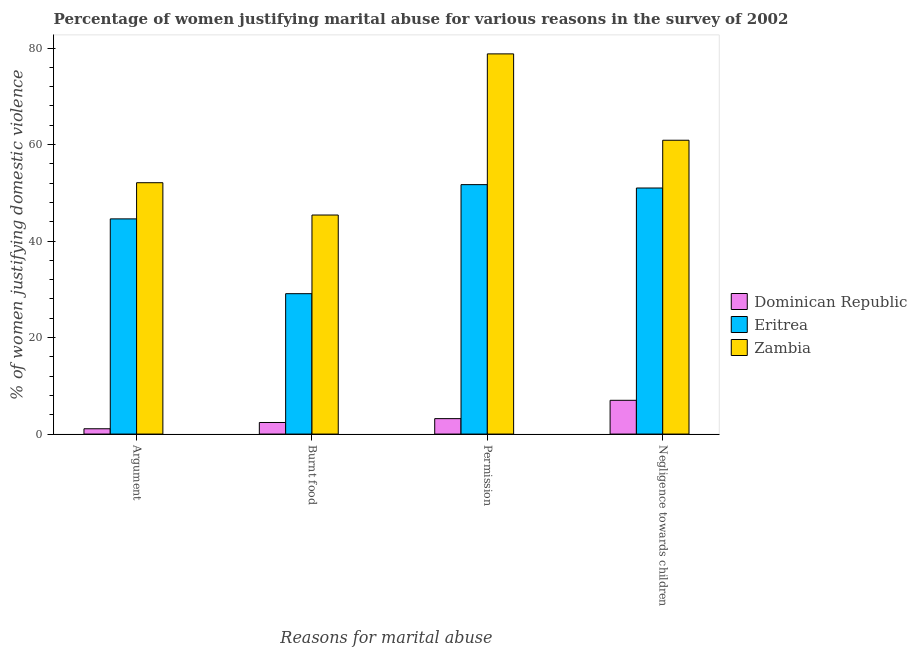How many bars are there on the 3rd tick from the left?
Provide a short and direct response. 3. How many bars are there on the 3rd tick from the right?
Keep it short and to the point. 3. What is the label of the 2nd group of bars from the left?
Offer a very short reply. Burnt food. What is the percentage of women justifying abuse in the case of an argument in Dominican Republic?
Your response must be concise. 1.1. Across all countries, what is the maximum percentage of women justifying abuse for going without permission?
Your answer should be very brief. 78.8. In which country was the percentage of women justifying abuse in the case of an argument maximum?
Your answer should be compact. Zambia. In which country was the percentage of women justifying abuse for burning food minimum?
Ensure brevity in your answer.  Dominican Republic. What is the total percentage of women justifying abuse for going without permission in the graph?
Offer a very short reply. 133.7. What is the difference between the percentage of women justifying abuse for showing negligence towards children in Dominican Republic and that in Zambia?
Make the answer very short. -53.9. What is the difference between the percentage of women justifying abuse for burning food in Eritrea and the percentage of women justifying abuse for going without permission in Dominican Republic?
Your answer should be compact. 25.9. What is the average percentage of women justifying abuse for showing negligence towards children per country?
Your answer should be compact. 39.63. What is the difference between the percentage of women justifying abuse for showing negligence towards children and percentage of women justifying abuse for going without permission in Zambia?
Provide a succinct answer. -17.9. In how many countries, is the percentage of women justifying abuse for showing negligence towards children greater than 20 %?
Give a very brief answer. 2. What is the ratio of the percentage of women justifying abuse in the case of an argument in Zambia to that in Eritrea?
Give a very brief answer. 1.17. What is the difference between the highest and the lowest percentage of women justifying abuse in the case of an argument?
Your answer should be very brief. 51. In how many countries, is the percentage of women justifying abuse for showing negligence towards children greater than the average percentage of women justifying abuse for showing negligence towards children taken over all countries?
Your answer should be compact. 2. Is it the case that in every country, the sum of the percentage of women justifying abuse for showing negligence towards children and percentage of women justifying abuse for going without permission is greater than the sum of percentage of women justifying abuse for burning food and percentage of women justifying abuse in the case of an argument?
Offer a very short reply. No. What does the 2nd bar from the left in Permission represents?
Provide a succinct answer. Eritrea. What does the 3rd bar from the right in Burnt food represents?
Ensure brevity in your answer.  Dominican Republic. Is it the case that in every country, the sum of the percentage of women justifying abuse in the case of an argument and percentage of women justifying abuse for burning food is greater than the percentage of women justifying abuse for going without permission?
Your answer should be compact. Yes. How many bars are there?
Provide a short and direct response. 12. How many countries are there in the graph?
Offer a very short reply. 3. What is the difference between two consecutive major ticks on the Y-axis?
Your answer should be compact. 20. Are the values on the major ticks of Y-axis written in scientific E-notation?
Offer a terse response. No. How many legend labels are there?
Ensure brevity in your answer.  3. What is the title of the graph?
Offer a very short reply. Percentage of women justifying marital abuse for various reasons in the survey of 2002. Does "Guam" appear as one of the legend labels in the graph?
Ensure brevity in your answer.  No. What is the label or title of the X-axis?
Ensure brevity in your answer.  Reasons for marital abuse. What is the label or title of the Y-axis?
Keep it short and to the point. % of women justifying domestic violence. What is the % of women justifying domestic violence of Dominican Republic in Argument?
Your answer should be very brief. 1.1. What is the % of women justifying domestic violence in Eritrea in Argument?
Provide a short and direct response. 44.6. What is the % of women justifying domestic violence of Zambia in Argument?
Your answer should be very brief. 52.1. What is the % of women justifying domestic violence of Dominican Republic in Burnt food?
Your answer should be very brief. 2.4. What is the % of women justifying domestic violence of Eritrea in Burnt food?
Your answer should be compact. 29.1. What is the % of women justifying domestic violence in Zambia in Burnt food?
Provide a succinct answer. 45.4. What is the % of women justifying domestic violence in Dominican Republic in Permission?
Give a very brief answer. 3.2. What is the % of women justifying domestic violence of Eritrea in Permission?
Offer a terse response. 51.7. What is the % of women justifying domestic violence in Zambia in Permission?
Offer a terse response. 78.8. What is the % of women justifying domestic violence of Dominican Republic in Negligence towards children?
Provide a succinct answer. 7. What is the % of women justifying domestic violence in Eritrea in Negligence towards children?
Provide a short and direct response. 51. What is the % of women justifying domestic violence in Zambia in Negligence towards children?
Offer a very short reply. 60.9. Across all Reasons for marital abuse, what is the maximum % of women justifying domestic violence of Eritrea?
Offer a terse response. 51.7. Across all Reasons for marital abuse, what is the maximum % of women justifying domestic violence in Zambia?
Provide a succinct answer. 78.8. Across all Reasons for marital abuse, what is the minimum % of women justifying domestic violence in Eritrea?
Offer a very short reply. 29.1. Across all Reasons for marital abuse, what is the minimum % of women justifying domestic violence of Zambia?
Provide a succinct answer. 45.4. What is the total % of women justifying domestic violence of Dominican Republic in the graph?
Your response must be concise. 13.7. What is the total % of women justifying domestic violence in Eritrea in the graph?
Make the answer very short. 176.4. What is the total % of women justifying domestic violence of Zambia in the graph?
Ensure brevity in your answer.  237.2. What is the difference between the % of women justifying domestic violence of Eritrea in Argument and that in Burnt food?
Offer a very short reply. 15.5. What is the difference between the % of women justifying domestic violence in Zambia in Argument and that in Burnt food?
Provide a short and direct response. 6.7. What is the difference between the % of women justifying domestic violence of Eritrea in Argument and that in Permission?
Give a very brief answer. -7.1. What is the difference between the % of women justifying domestic violence in Zambia in Argument and that in Permission?
Your answer should be compact. -26.7. What is the difference between the % of women justifying domestic violence in Dominican Republic in Argument and that in Negligence towards children?
Your answer should be compact. -5.9. What is the difference between the % of women justifying domestic violence of Eritrea in Argument and that in Negligence towards children?
Offer a terse response. -6.4. What is the difference between the % of women justifying domestic violence of Eritrea in Burnt food and that in Permission?
Offer a very short reply. -22.6. What is the difference between the % of women justifying domestic violence in Zambia in Burnt food and that in Permission?
Make the answer very short. -33.4. What is the difference between the % of women justifying domestic violence in Eritrea in Burnt food and that in Negligence towards children?
Give a very brief answer. -21.9. What is the difference between the % of women justifying domestic violence of Zambia in Burnt food and that in Negligence towards children?
Provide a succinct answer. -15.5. What is the difference between the % of women justifying domestic violence of Eritrea in Permission and that in Negligence towards children?
Your response must be concise. 0.7. What is the difference between the % of women justifying domestic violence of Zambia in Permission and that in Negligence towards children?
Your response must be concise. 17.9. What is the difference between the % of women justifying domestic violence of Dominican Republic in Argument and the % of women justifying domestic violence of Zambia in Burnt food?
Your answer should be very brief. -44.3. What is the difference between the % of women justifying domestic violence in Eritrea in Argument and the % of women justifying domestic violence in Zambia in Burnt food?
Offer a terse response. -0.8. What is the difference between the % of women justifying domestic violence of Dominican Republic in Argument and the % of women justifying domestic violence of Eritrea in Permission?
Ensure brevity in your answer.  -50.6. What is the difference between the % of women justifying domestic violence in Dominican Republic in Argument and the % of women justifying domestic violence in Zambia in Permission?
Give a very brief answer. -77.7. What is the difference between the % of women justifying domestic violence in Eritrea in Argument and the % of women justifying domestic violence in Zambia in Permission?
Provide a succinct answer. -34.2. What is the difference between the % of women justifying domestic violence in Dominican Republic in Argument and the % of women justifying domestic violence in Eritrea in Negligence towards children?
Give a very brief answer. -49.9. What is the difference between the % of women justifying domestic violence of Dominican Republic in Argument and the % of women justifying domestic violence of Zambia in Negligence towards children?
Provide a short and direct response. -59.8. What is the difference between the % of women justifying domestic violence of Eritrea in Argument and the % of women justifying domestic violence of Zambia in Negligence towards children?
Offer a terse response. -16.3. What is the difference between the % of women justifying domestic violence in Dominican Republic in Burnt food and the % of women justifying domestic violence in Eritrea in Permission?
Keep it short and to the point. -49.3. What is the difference between the % of women justifying domestic violence of Dominican Republic in Burnt food and the % of women justifying domestic violence of Zambia in Permission?
Give a very brief answer. -76.4. What is the difference between the % of women justifying domestic violence in Eritrea in Burnt food and the % of women justifying domestic violence in Zambia in Permission?
Your answer should be very brief. -49.7. What is the difference between the % of women justifying domestic violence in Dominican Republic in Burnt food and the % of women justifying domestic violence in Eritrea in Negligence towards children?
Offer a terse response. -48.6. What is the difference between the % of women justifying domestic violence of Dominican Republic in Burnt food and the % of women justifying domestic violence of Zambia in Negligence towards children?
Give a very brief answer. -58.5. What is the difference between the % of women justifying domestic violence in Eritrea in Burnt food and the % of women justifying domestic violence in Zambia in Negligence towards children?
Offer a very short reply. -31.8. What is the difference between the % of women justifying domestic violence of Dominican Republic in Permission and the % of women justifying domestic violence of Eritrea in Negligence towards children?
Your response must be concise. -47.8. What is the difference between the % of women justifying domestic violence in Dominican Republic in Permission and the % of women justifying domestic violence in Zambia in Negligence towards children?
Provide a short and direct response. -57.7. What is the difference between the % of women justifying domestic violence of Eritrea in Permission and the % of women justifying domestic violence of Zambia in Negligence towards children?
Make the answer very short. -9.2. What is the average % of women justifying domestic violence of Dominican Republic per Reasons for marital abuse?
Make the answer very short. 3.42. What is the average % of women justifying domestic violence of Eritrea per Reasons for marital abuse?
Offer a terse response. 44.1. What is the average % of women justifying domestic violence of Zambia per Reasons for marital abuse?
Your answer should be compact. 59.3. What is the difference between the % of women justifying domestic violence of Dominican Republic and % of women justifying domestic violence of Eritrea in Argument?
Offer a terse response. -43.5. What is the difference between the % of women justifying domestic violence in Dominican Republic and % of women justifying domestic violence in Zambia in Argument?
Your answer should be compact. -51. What is the difference between the % of women justifying domestic violence in Eritrea and % of women justifying domestic violence in Zambia in Argument?
Your response must be concise. -7.5. What is the difference between the % of women justifying domestic violence of Dominican Republic and % of women justifying domestic violence of Eritrea in Burnt food?
Provide a short and direct response. -26.7. What is the difference between the % of women justifying domestic violence in Dominican Republic and % of women justifying domestic violence in Zambia in Burnt food?
Keep it short and to the point. -43. What is the difference between the % of women justifying domestic violence in Eritrea and % of women justifying domestic violence in Zambia in Burnt food?
Your answer should be very brief. -16.3. What is the difference between the % of women justifying domestic violence in Dominican Republic and % of women justifying domestic violence in Eritrea in Permission?
Offer a very short reply. -48.5. What is the difference between the % of women justifying domestic violence of Dominican Republic and % of women justifying domestic violence of Zambia in Permission?
Offer a very short reply. -75.6. What is the difference between the % of women justifying domestic violence in Eritrea and % of women justifying domestic violence in Zambia in Permission?
Keep it short and to the point. -27.1. What is the difference between the % of women justifying domestic violence of Dominican Republic and % of women justifying domestic violence of Eritrea in Negligence towards children?
Your response must be concise. -44. What is the difference between the % of women justifying domestic violence of Dominican Republic and % of women justifying domestic violence of Zambia in Negligence towards children?
Ensure brevity in your answer.  -53.9. What is the ratio of the % of women justifying domestic violence in Dominican Republic in Argument to that in Burnt food?
Offer a terse response. 0.46. What is the ratio of the % of women justifying domestic violence of Eritrea in Argument to that in Burnt food?
Your answer should be compact. 1.53. What is the ratio of the % of women justifying domestic violence of Zambia in Argument to that in Burnt food?
Provide a short and direct response. 1.15. What is the ratio of the % of women justifying domestic violence of Dominican Republic in Argument to that in Permission?
Keep it short and to the point. 0.34. What is the ratio of the % of women justifying domestic violence in Eritrea in Argument to that in Permission?
Your answer should be very brief. 0.86. What is the ratio of the % of women justifying domestic violence in Zambia in Argument to that in Permission?
Ensure brevity in your answer.  0.66. What is the ratio of the % of women justifying domestic violence of Dominican Republic in Argument to that in Negligence towards children?
Your answer should be very brief. 0.16. What is the ratio of the % of women justifying domestic violence in Eritrea in Argument to that in Negligence towards children?
Provide a short and direct response. 0.87. What is the ratio of the % of women justifying domestic violence in Zambia in Argument to that in Negligence towards children?
Keep it short and to the point. 0.86. What is the ratio of the % of women justifying domestic violence of Dominican Republic in Burnt food to that in Permission?
Ensure brevity in your answer.  0.75. What is the ratio of the % of women justifying domestic violence of Eritrea in Burnt food to that in Permission?
Your answer should be compact. 0.56. What is the ratio of the % of women justifying domestic violence of Zambia in Burnt food to that in Permission?
Your response must be concise. 0.58. What is the ratio of the % of women justifying domestic violence in Dominican Republic in Burnt food to that in Negligence towards children?
Your response must be concise. 0.34. What is the ratio of the % of women justifying domestic violence of Eritrea in Burnt food to that in Negligence towards children?
Make the answer very short. 0.57. What is the ratio of the % of women justifying domestic violence in Zambia in Burnt food to that in Negligence towards children?
Your answer should be compact. 0.75. What is the ratio of the % of women justifying domestic violence in Dominican Republic in Permission to that in Negligence towards children?
Your answer should be compact. 0.46. What is the ratio of the % of women justifying domestic violence in Eritrea in Permission to that in Negligence towards children?
Keep it short and to the point. 1.01. What is the ratio of the % of women justifying domestic violence in Zambia in Permission to that in Negligence towards children?
Offer a terse response. 1.29. What is the difference between the highest and the second highest % of women justifying domestic violence in Zambia?
Make the answer very short. 17.9. What is the difference between the highest and the lowest % of women justifying domestic violence of Eritrea?
Make the answer very short. 22.6. What is the difference between the highest and the lowest % of women justifying domestic violence in Zambia?
Your answer should be very brief. 33.4. 